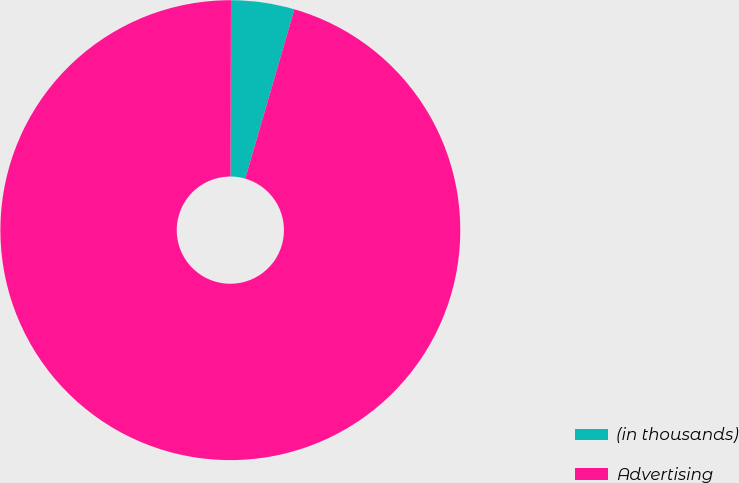Convert chart. <chart><loc_0><loc_0><loc_500><loc_500><pie_chart><fcel>(in thousands)<fcel>Advertising<nl><fcel>4.45%<fcel>95.55%<nl></chart> 